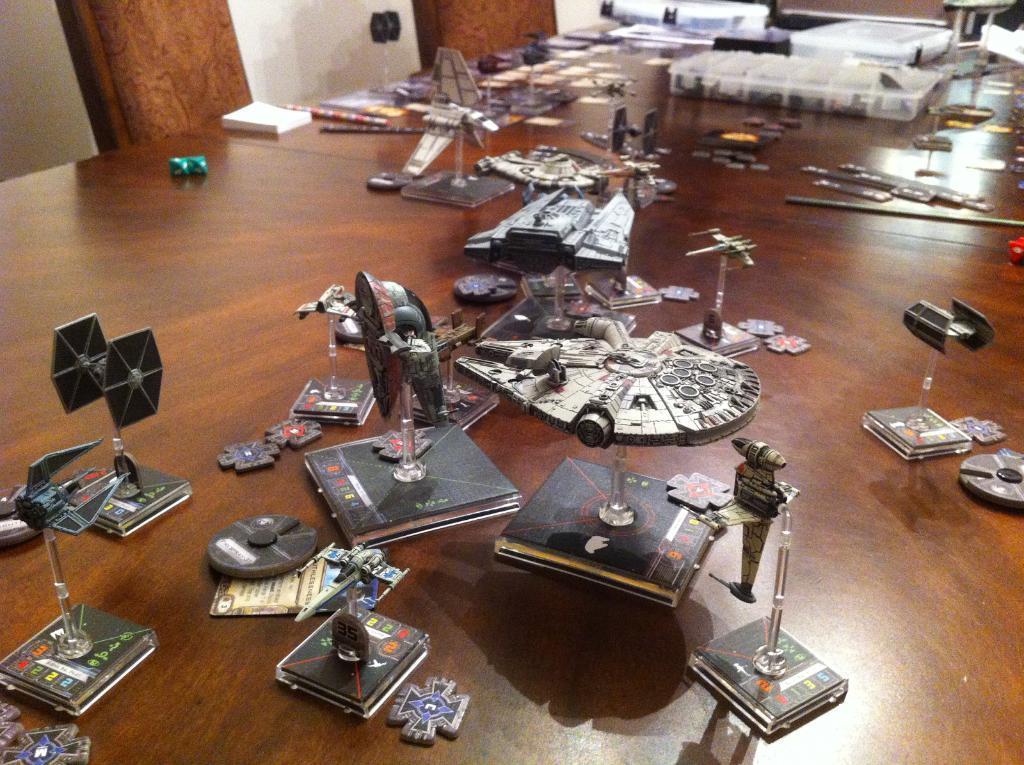In one or two sentences, can you explain what this image depicts? In this picture we can see a few books and other objects on the tables. There are chairs and a wall in the background. 